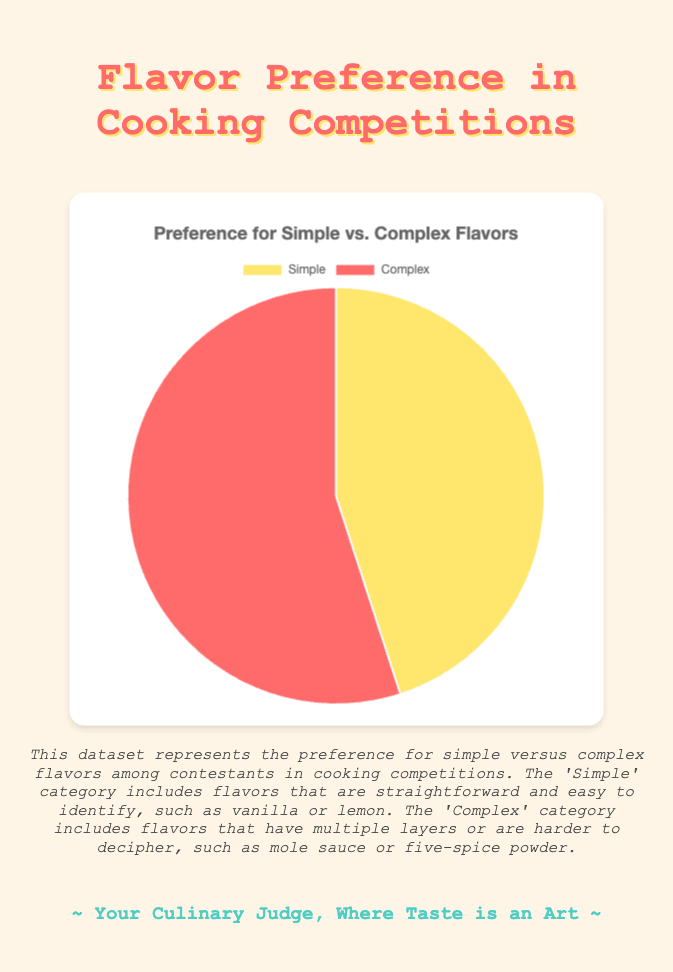Preference for Simple vs. Complex Flavors? To determine the preference for simple versus complex flavors, look at the percentage slices in the pie chart. The simple flavors are represented by 45%, and complex flavors by 55%
Answer: Complex Which flavor type has the larger share of preference? To answer this, compare the size of the slices in the pie chart. The complex flavor slice is larger than the simple flavor slice.
Answer: Complex Is there a significant difference in the preferences for simple versus complex flavors? By observing the percentage values in the pie chart, we can see that the difference between the two categories is 10%. This indicates a noticeable preference difference.
Answer: Yes Approximately what fraction of the contestants prefer simple flavors? The pie chart shows that 45% of the contestants prefer simple flavors. This translates to approximately 9/20 when converted to fraction form.
Answer: 9/20 What is the ratio of contestants who prefer simple flavors to those who prefer complex flavors? From the pie chart, we know that 45% prefer simple flavors and 55% prefer complex flavors. The ratio is 45:55, which simplifies to 9:11.
Answer: 9:11 Which color represents the simple flavors in the pie chart? Observing the pie chart, the slice representing simple flavors is colored yellow. The specific hue is not needed; yellow suffices.
Answer: Yellow Which category is dominating in the pie chart and by how much? To determine the dominating category, compare the two value percentages. The complex flavors dominate by 10% over the simple flavors.
Answer: Complex by 10% What combined percentage of contestants prefer either simple or complex flavors? Sum the percentages of both flavor preferences: 45% (simple) + 55% (complex) = 100%. This confirms that all contestants prefer one of the two categories.
Answer: 100% If you were to taste dishes from all contestants, how many dishes would you expect to have complex flavors if 100 contestants participated? With 55% of contestants preferring complex flavors, we expect 55 out of 100 dishes to have complex flavors since 55% of 100 is 55.
Answer: 55 